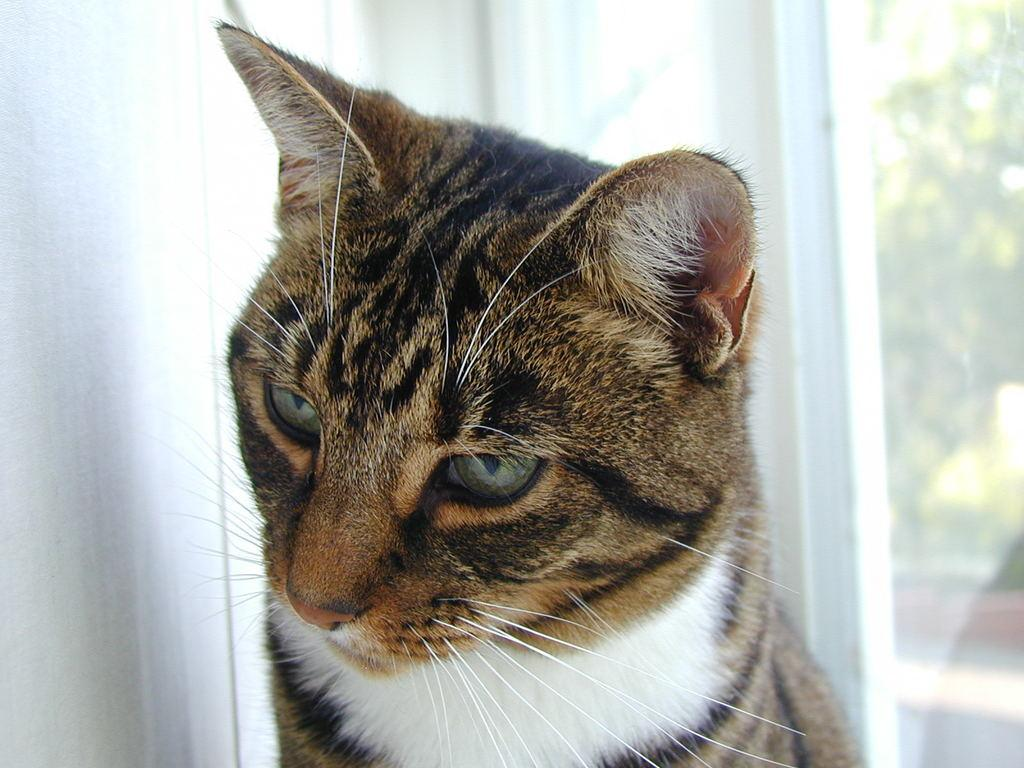What type of animal is in the image? There is a cat in the image. What is located beside the cat? There is a wall beside the cat. What is located behind the cat? There is a glass door behind the cat. What type of butter is being used by the cat in the image? There is no butter present in the image, and the cat is not using any butter. 